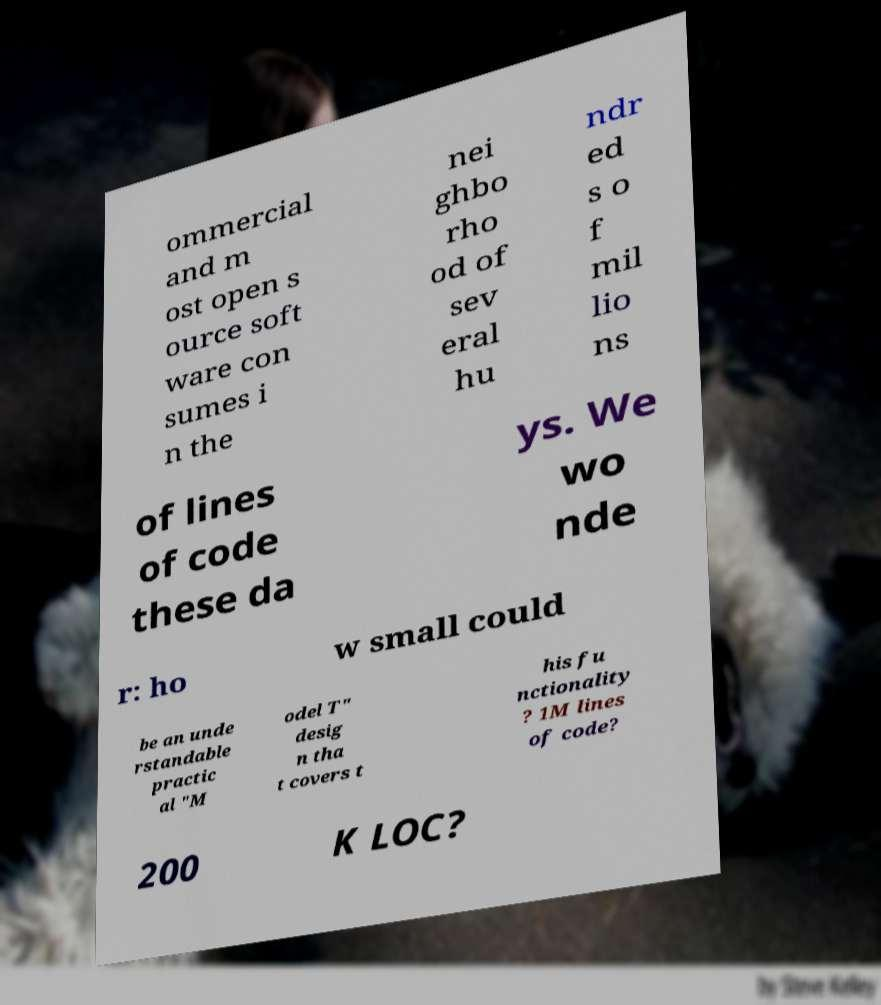Can you accurately transcribe the text from the provided image for me? ommercial and m ost open s ource soft ware con sumes i n the nei ghbo rho od of sev eral hu ndr ed s o f mil lio ns of lines of code these da ys. We wo nde r: ho w small could be an unde rstandable practic al "M odel T" desig n tha t covers t his fu nctionality ? 1M lines of code? 200 K LOC? 